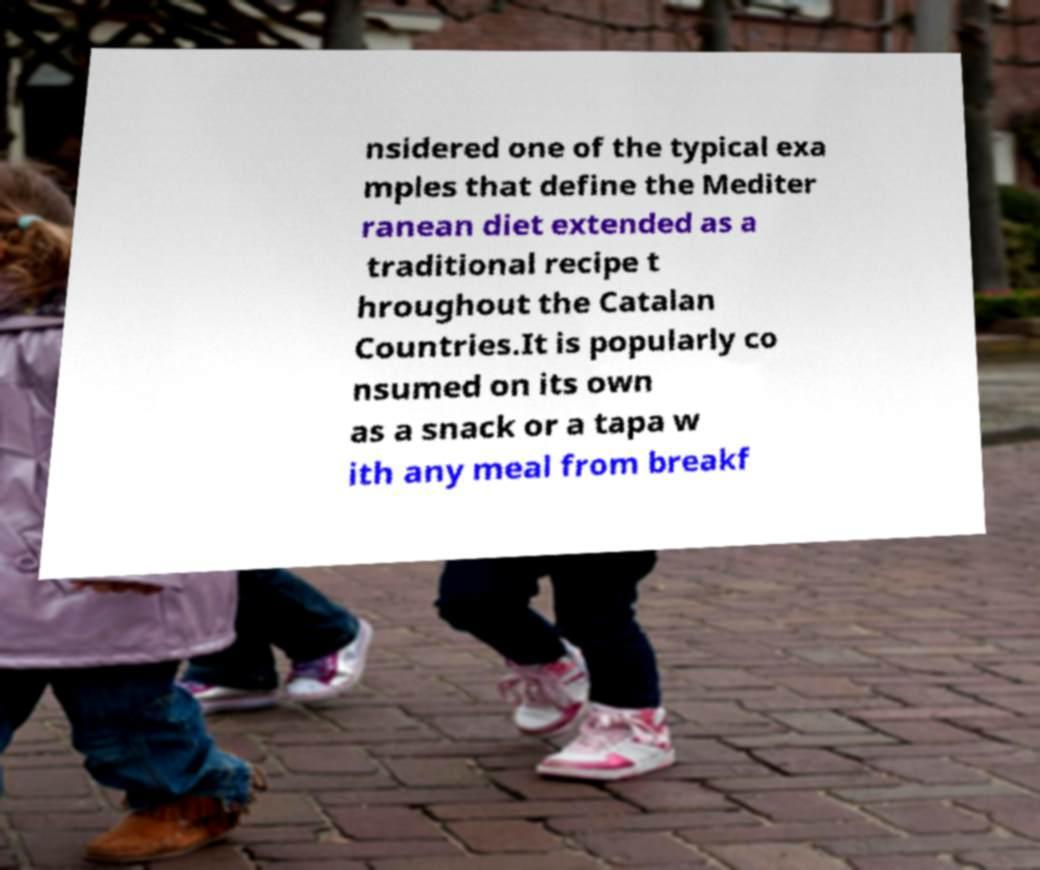Please read and relay the text visible in this image. What does it say? nsidered one of the typical exa mples that define the Mediter ranean diet extended as a traditional recipe t hroughout the Catalan Countries.It is popularly co nsumed on its own as a snack or a tapa w ith any meal from breakf 